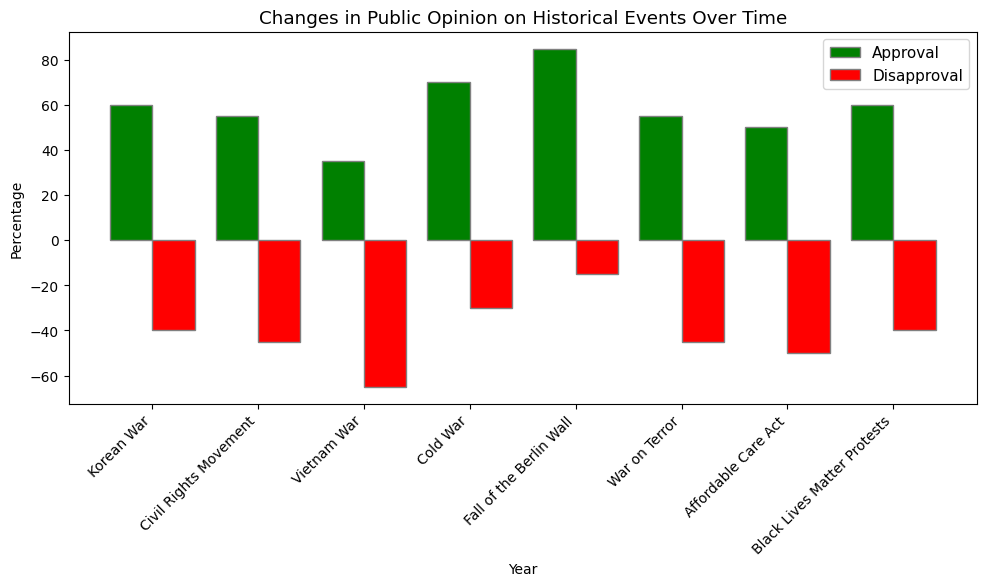Which historical event in the chart has the highest approval rating? Looking at the height of the green bars, the event "Fall of the Berlin Wall" in 1990 has the highest approval rating at 85%.
Answer: Fall of the Berlin Wall Which historical event has the smallest difference between approval and disapproval ratings? Calculate the difference between approval and disapproval ratings for each event: Korean War: 60-(-40)=100, Civil Rights Movement: 55-(-45)=100, Vietnam War: 35-(-65)=100, Cold War: 70-(-30)=100, Fall of the Berlin Wall: 85-(-15)=100, War on Terror: 55-(-45)=100, Affordable Care Act: 50-(-50)=100, Black Lives Matter Protests: 60-(-40)=100. All events have a difference of 100.
Answer: All events Which event has the most balanced public opinion (approval and disapproval ratings closest to each other)? Find the event where the absolute difference between approval and disapproval ratings is the smallest. In the data, all events have an absolute difference of 100%. Therefore, all events are equally balanced.
Answer: All events What is the average approval rating for all historical events shown in the chart? Sum all approval ratings and divide by the number of events: (60 + 55 + 35 + 70 + 85 + 55 + 50 + 60) / 8 = 470 / 8 = 58.75
Answer: 58.75 Compare the approval rating of the Civil Rights Movement in 1960 to the approval rating of the War on Terror in 2000. Which is higher? The Civil Rights Movement has an approval rating of 55%, while the War on Terror also has an approval rating of 55%. Both are the same.
Answer: They are equal What is the most disapproved historical event shown on the chart? The highest negative red bar represents the most disapproved event. The Vietnam War (1970) has the highest disapproval rating at -65%.
Answer: Vietnam War In which decade do public opinions on historical events show the most positive sentiment? Summarize the approval ratings for each decade to see which one is the highest. The 1990s have the highest approval with 85% for the Fall of the Berlin Wall.
Answer: 1990s What is the cumulative approval rating for the events in the 20th century? Add approval ratings for events from 1950 to 1999: (60 + 55 + 35 + 70 + 85) = 305.
Answer: 305 Which historical event has the least disapproval rating? The smallest negative red bar represents the least disapproved event. The Fall of the Berlin Wall (1990) has the least disapproval rating at -15%.
Answer: Fall of the Berlin Wall 